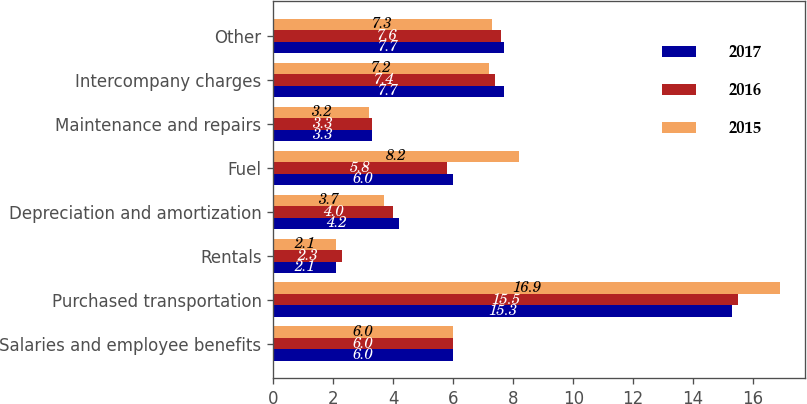Convert chart. <chart><loc_0><loc_0><loc_500><loc_500><stacked_bar_chart><ecel><fcel>Salaries and employee benefits<fcel>Purchased transportation<fcel>Rentals<fcel>Depreciation and amortization<fcel>Fuel<fcel>Maintenance and repairs<fcel>Intercompany charges<fcel>Other<nl><fcel>2017<fcel>6<fcel>15.3<fcel>2.1<fcel>4.2<fcel>6<fcel>3.3<fcel>7.7<fcel>7.7<nl><fcel>2016<fcel>6<fcel>15.5<fcel>2.3<fcel>4<fcel>5.8<fcel>3.3<fcel>7.4<fcel>7.6<nl><fcel>2015<fcel>6<fcel>16.9<fcel>2.1<fcel>3.7<fcel>8.2<fcel>3.2<fcel>7.2<fcel>7.3<nl></chart> 